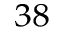<formula> <loc_0><loc_0><loc_500><loc_500>^ { 3 8 }</formula> 